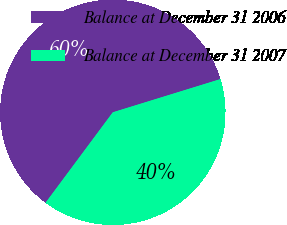Convert chart. <chart><loc_0><loc_0><loc_500><loc_500><pie_chart><fcel>Balance at December 31 2006<fcel>Balance at December 31 2007<nl><fcel>60.06%<fcel>39.94%<nl></chart> 